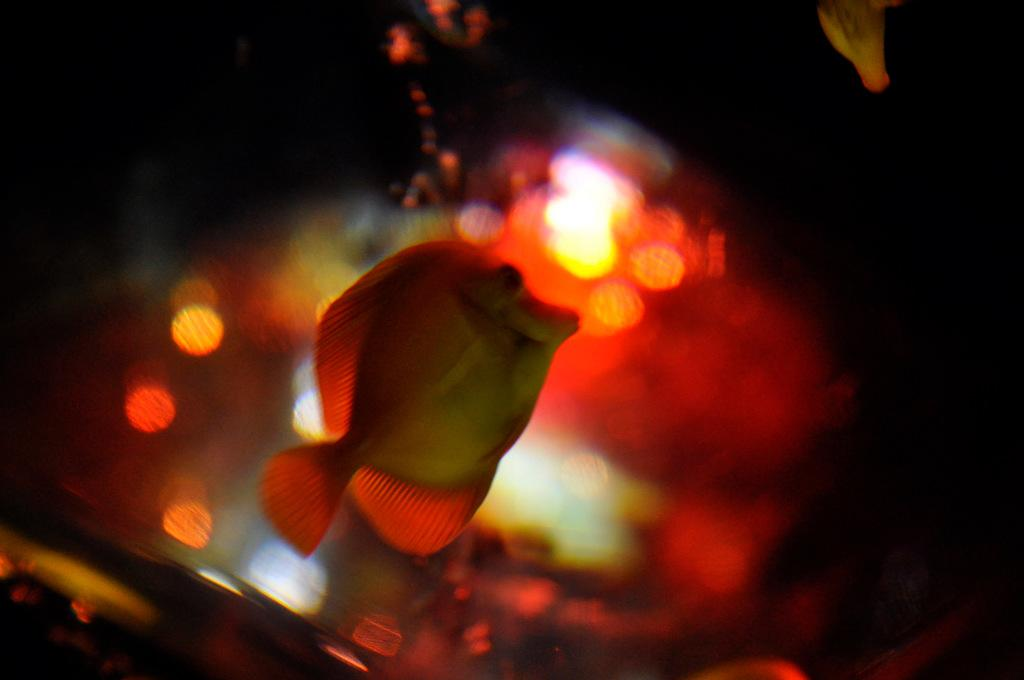What is the main subject in the foreground of the image? There is a fish in the water in the foreground of the image. What color is the light visible in the background of the image? There is a red light in the background of the image. Can you describe any other potential subjects in the image? There may be another fish on top in the image. What type of beast can be seen kicking a ball in the image? There is no beast or ball present in the image; it features a fish in the water and a red light in the background. 